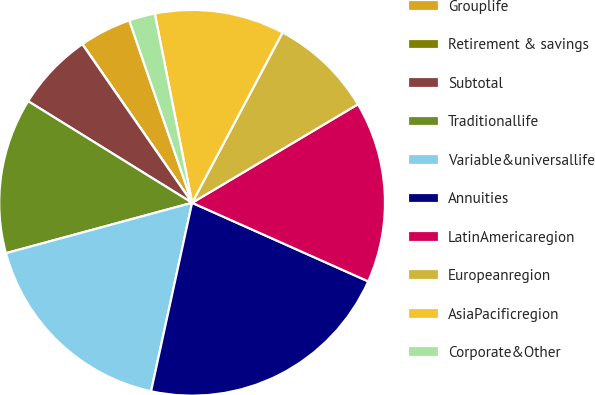Convert chart. <chart><loc_0><loc_0><loc_500><loc_500><pie_chart><fcel>Grouplife<fcel>Retirement & savings<fcel>Subtotal<fcel>Traditionallife<fcel>Variable&universallife<fcel>Annuities<fcel>LatinAmericaregion<fcel>Europeanregion<fcel>AsiaPacificregion<fcel>Corporate&Other<nl><fcel>4.35%<fcel>0.01%<fcel>6.53%<fcel>13.04%<fcel>17.38%<fcel>21.73%<fcel>15.21%<fcel>8.7%<fcel>10.87%<fcel>2.18%<nl></chart> 